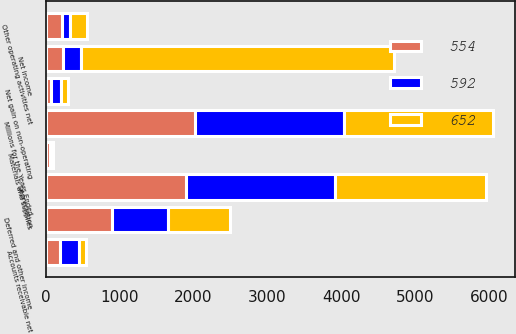<chart> <loc_0><loc_0><loc_500><loc_500><stacked_bar_chart><ecel><fcel>Millions for the Years Ended<fcel>Net income<fcel>Depreciation<fcel>Deferred and other income<fcel>Net gain on non-operating<fcel>Other operating activities net<fcel>Accounts receivable net<fcel>Materials and supplies<nl><fcel>652<fcel>2016<fcel>4233<fcel>2038<fcel>831<fcel>94<fcel>228<fcel>98<fcel>19<nl><fcel>592<fcel>2015<fcel>241.5<fcel>2012<fcel>765<fcel>144<fcel>116<fcel>255<fcel>24<nl><fcel>554<fcel>2014<fcel>241.5<fcel>1904<fcel>895<fcel>69<fcel>216<fcel>197<fcel>59<nl></chart> 